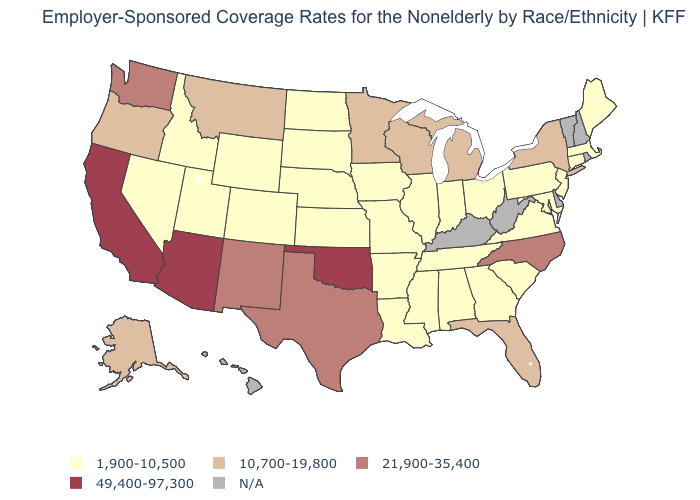Among the states that border Louisiana , does Texas have the lowest value?
Give a very brief answer. No. How many symbols are there in the legend?
Write a very short answer. 5. Which states hav the highest value in the MidWest?
Answer briefly. Michigan, Minnesota, Wisconsin. What is the value of Oklahoma?
Be succinct. 49,400-97,300. Does Florida have the lowest value in the USA?
Quick response, please. No. Does Louisiana have the lowest value in the USA?
Short answer required. Yes. Does the map have missing data?
Write a very short answer. Yes. Does Alabama have the highest value in the South?
Be succinct. No. Does California have the highest value in the USA?
Quick response, please. Yes. Name the states that have a value in the range 10,700-19,800?
Give a very brief answer. Alaska, Florida, Michigan, Minnesota, Montana, New York, Oregon, Wisconsin. Does New York have the lowest value in the Northeast?
Keep it brief. No. Does North Carolina have the lowest value in the USA?
Answer briefly. No. 